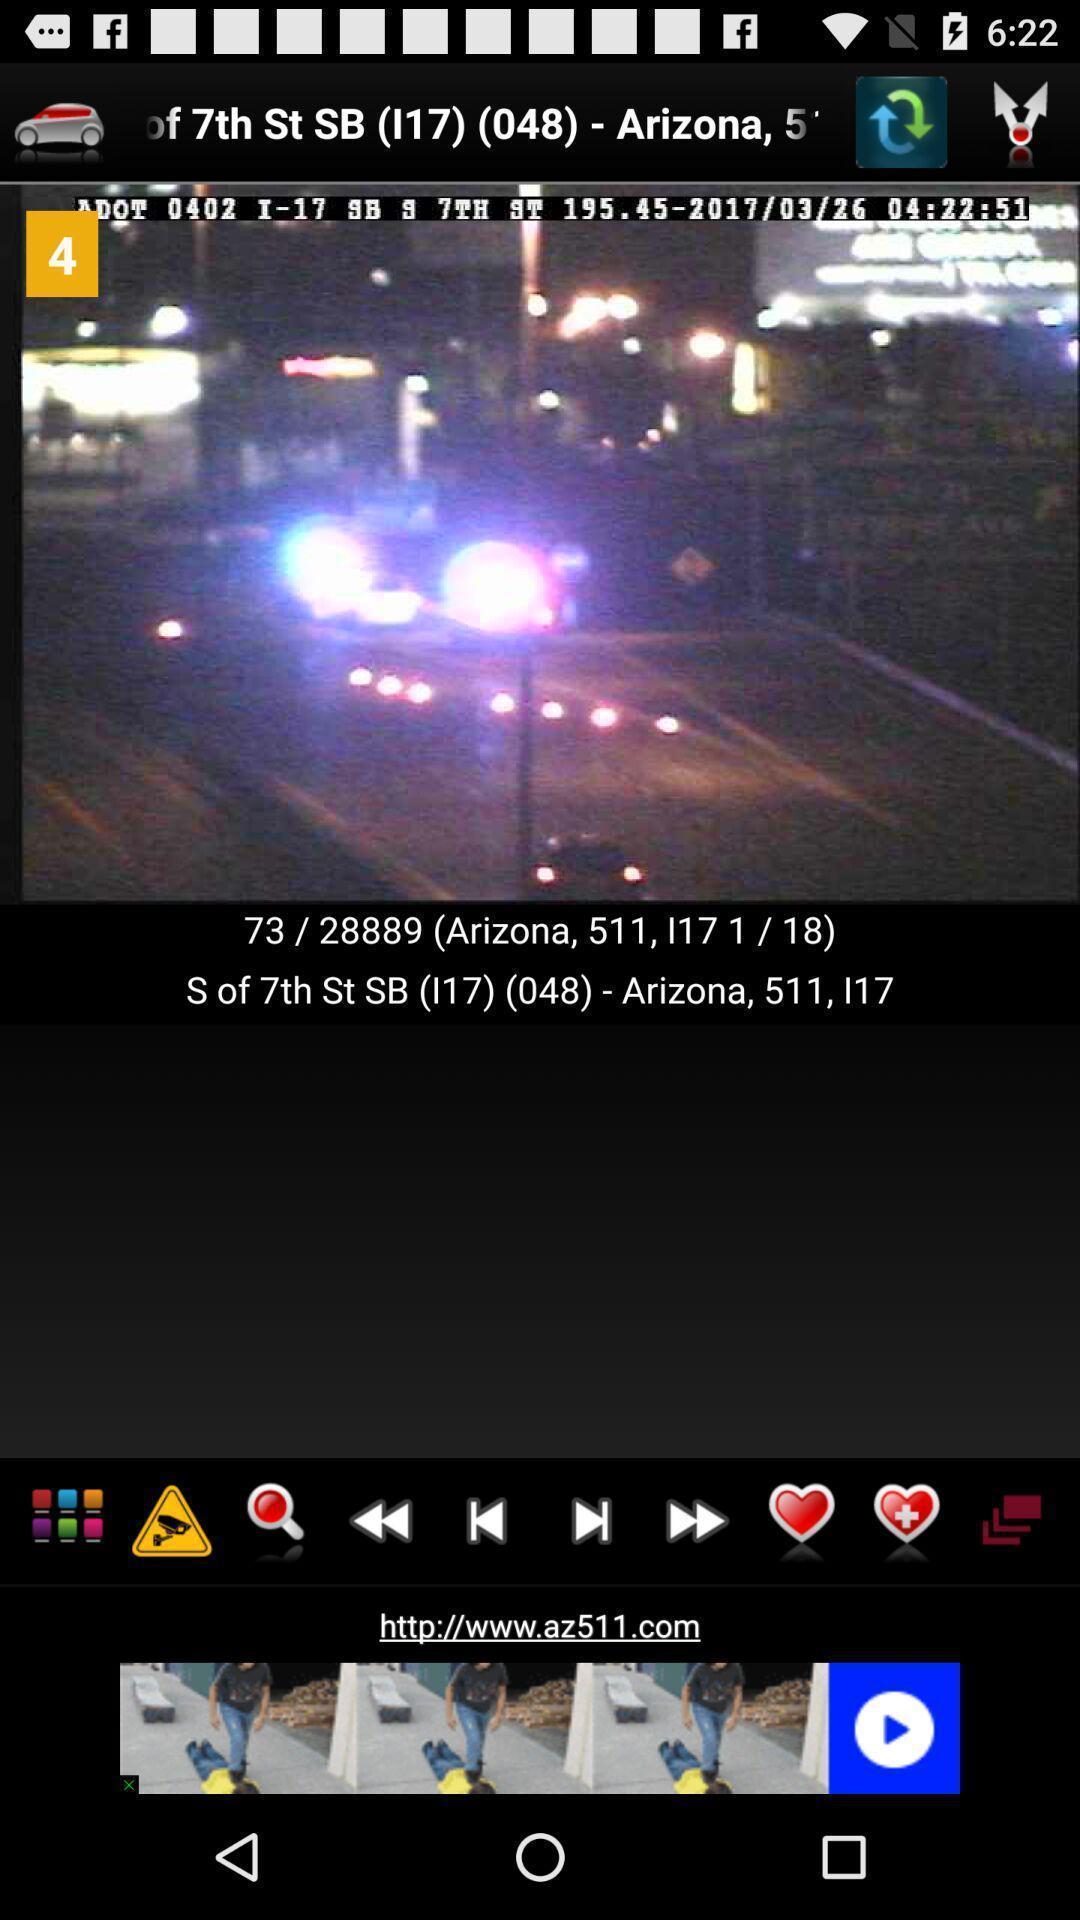Give me a narrative description of this picture. Screen page displaying an image with various options in application. 